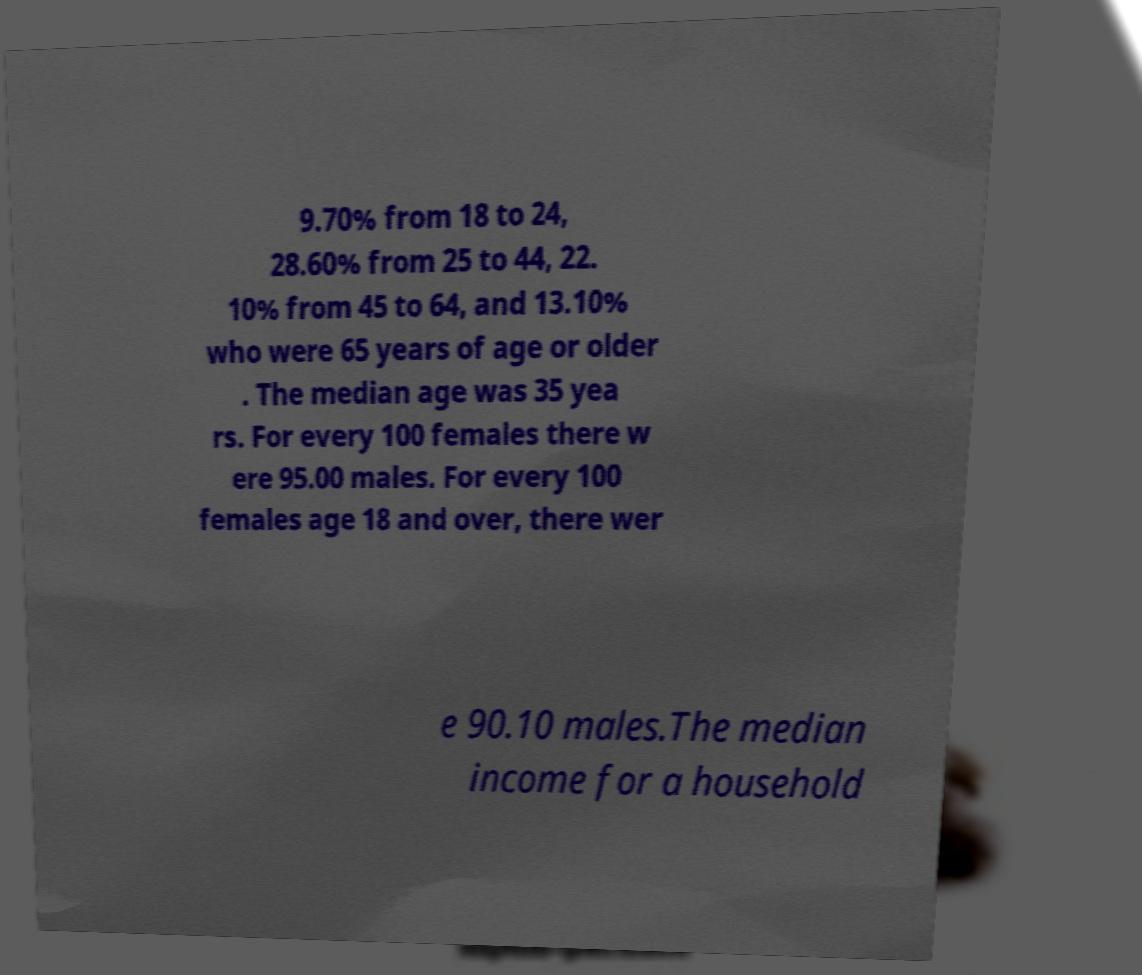Could you assist in decoding the text presented in this image and type it out clearly? 9.70% from 18 to 24, 28.60% from 25 to 44, 22. 10% from 45 to 64, and 13.10% who were 65 years of age or older . The median age was 35 yea rs. For every 100 females there w ere 95.00 males. For every 100 females age 18 and over, there wer e 90.10 males.The median income for a household 